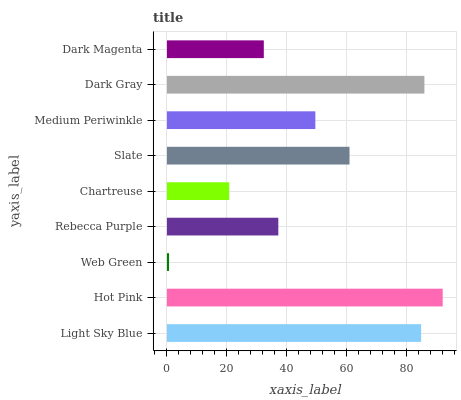Is Web Green the minimum?
Answer yes or no. Yes. Is Hot Pink the maximum?
Answer yes or no. Yes. Is Hot Pink the minimum?
Answer yes or no. No. Is Web Green the maximum?
Answer yes or no. No. Is Hot Pink greater than Web Green?
Answer yes or no. Yes. Is Web Green less than Hot Pink?
Answer yes or no. Yes. Is Web Green greater than Hot Pink?
Answer yes or no. No. Is Hot Pink less than Web Green?
Answer yes or no. No. Is Medium Periwinkle the high median?
Answer yes or no. Yes. Is Medium Periwinkle the low median?
Answer yes or no. Yes. Is Slate the high median?
Answer yes or no. No. Is Light Sky Blue the low median?
Answer yes or no. No. 